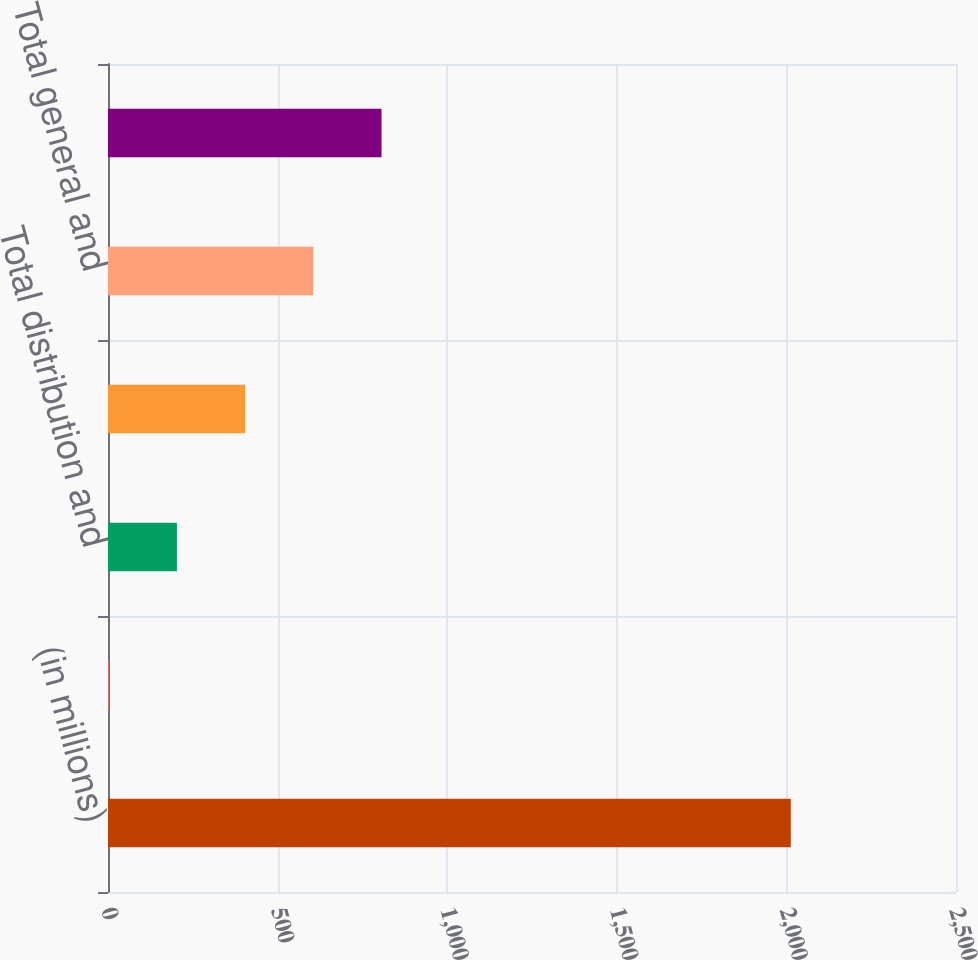Convert chart. <chart><loc_0><loc_0><loc_500><loc_500><bar_chart><fcel>(in millions)<fcel>PNC and affiliates<fcel>Total distribution and<fcel>Other registered investment<fcel>Total general and<fcel>Total expenses with related<nl><fcel>2013<fcel>2<fcel>203.1<fcel>404.2<fcel>605.3<fcel>806.4<nl></chart> 